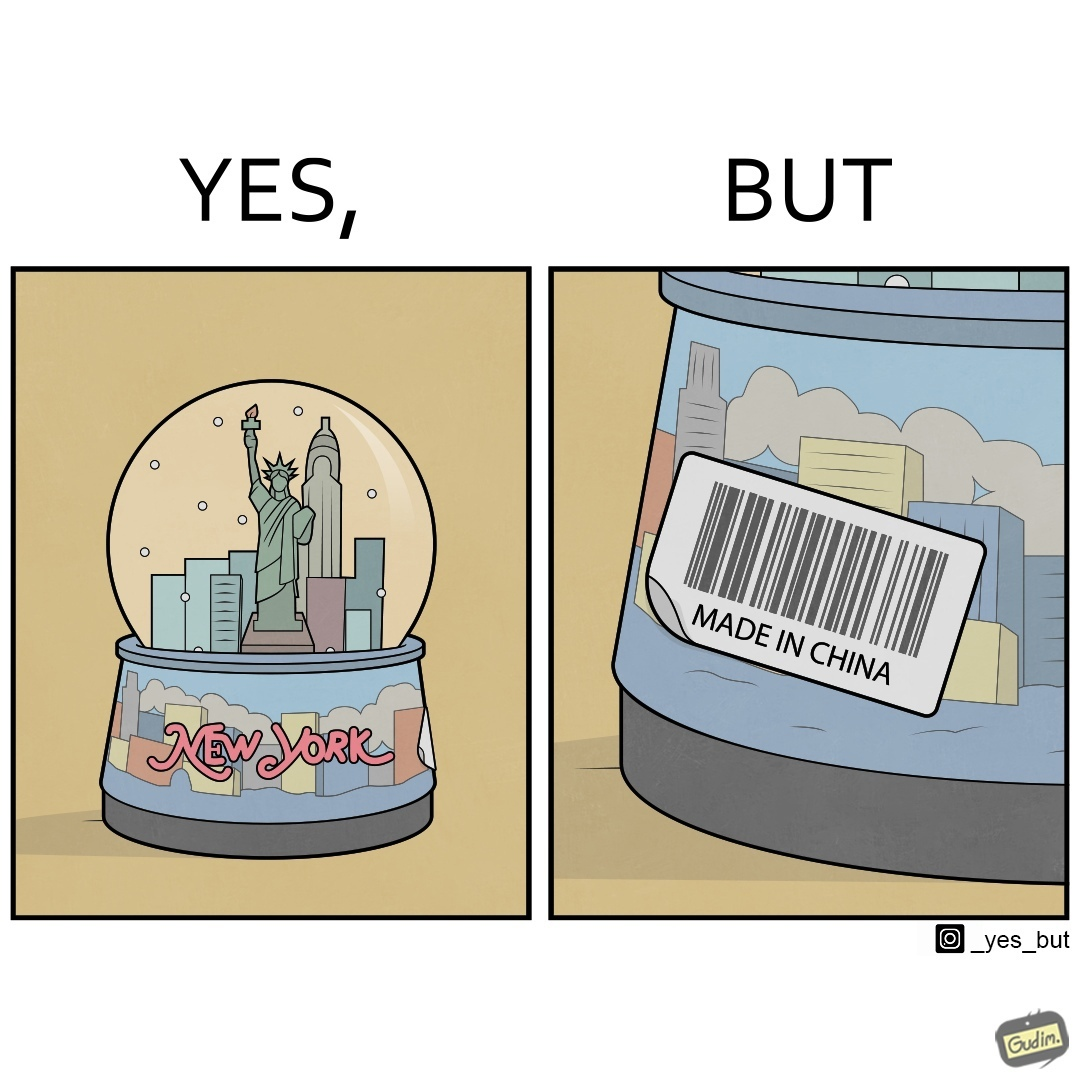Would you classify this image as satirical? Yes, this image is satirical. 